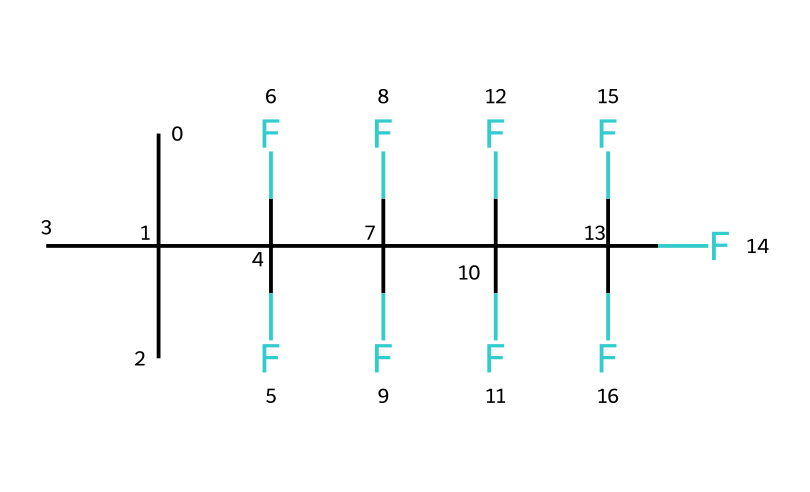What is the primary functional group in this chemical? The chemical structure includes many fluorine atoms and carbons, indicative of a fluorinated organic compound, but it does not contain typical functional groups like hydroxyl or amino. Instead, it emphasizes the hydrophobic nature due to the presence of fluorine.
Answer: fluorinated organic compound How many carbon atoms are present in this structure? By analyzing the SMILES notation, we count the 'C's present. There are a total of 8 carbon atoms in this structure.
Answer: 8 What type of bonding is predominantly present in this compound? The description shows multiple carbon-fluorine (C-F) bonds, which are characteristic of strong covalent bonds. There are no ionic or metallic bonds indicated in the structure.
Answer: covalent What property does the fluorine provide to swimwear fabric? Fluorine atoms contribute to the hydrophobic properties of the coating, making it repel water effectively, which is key for swimwear.
Answer: hydrophobic How does the branching in carbon structure affect its properties? The branching of carbon atoms in this structure can reduce surface area while maintaining a high number of fluorinated sites, enhancing water repellency and flexibility in the fabric.
Answer: enhances versatility What is the expected interaction of this chemical with water? The highly fluorinated structure will exhibit very low interaction with water due to its hydrophobic character, leading to minimal water absorption.
Answer: minimal interaction 